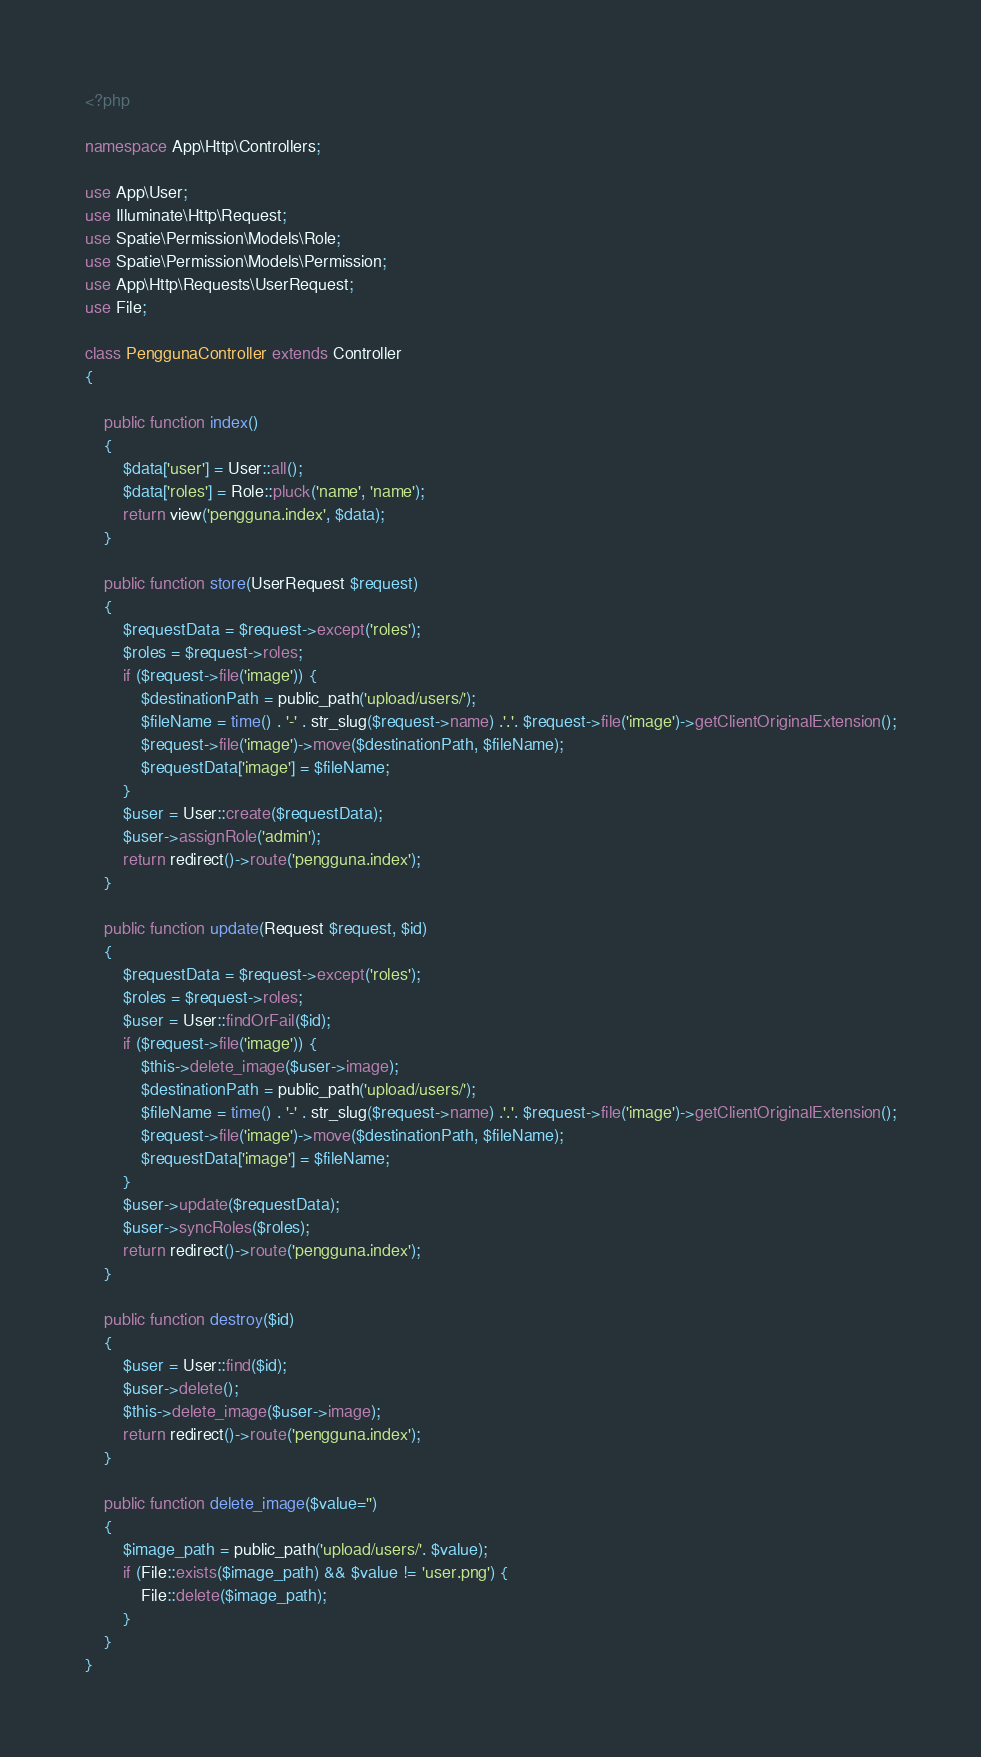Convert code to text. <code><loc_0><loc_0><loc_500><loc_500><_PHP_><?php

namespace App\Http\Controllers;

use App\User;
use Illuminate\Http\Request;
use Spatie\Permission\Models\Role;
use Spatie\Permission\Models\Permission;
use App\Http\Requests\UserRequest;
use File;

class PenggunaController extends Controller
{

    public function index()
    {
        $data['user'] = User::all();
        $data['roles'] = Role::pluck('name', 'name');
        return view('pengguna.index', $data);
    }

    public function store(UserRequest $request)
    {
        $requestData = $request->except('roles');
        $roles = $request->roles;
        if ($request->file('image')) {
            $destinationPath = public_path('upload/users/');
            $fileName = time() . '-' . str_slug($request->name) .'.'. $request->file('image')->getClientOriginalExtension();
            $request->file('image')->move($destinationPath, $fileName);
            $requestData['image'] = $fileName;
        }
        $user = User::create($requestData);
        $user->assignRole('admin');
        return redirect()->route('pengguna.index');
    }

    public function update(Request $request, $id)
    {
        $requestData = $request->except('roles');
        $roles = $request->roles;
        $user = User::findOrFail($id);
        if ($request->file('image')) {
            $this->delete_image($user->image);
            $destinationPath = public_path('upload/users/');
            $fileName = time() . '-' . str_slug($request->name) .'.'. $request->file('image')->getClientOriginalExtension();
            $request->file('image')->move($destinationPath, $fileName);
            $requestData['image'] = $fileName;
        }
        $user->update($requestData);
        $user->syncRoles($roles);
        return redirect()->route('pengguna.index'); 
    }

    public function destroy($id)
    {
        $user = User::find($id);
        $user->delete();
        $this->delete_image($user->image);
        return redirect()->route('pengguna.index');
    }

    public function delete_image($value='')
    {
        $image_path = public_path('upload/users/'. $value);
        if (File::exists($image_path) && $value != 'user.png') {
            File::delete($image_path);
        }
    }
}
</code> 